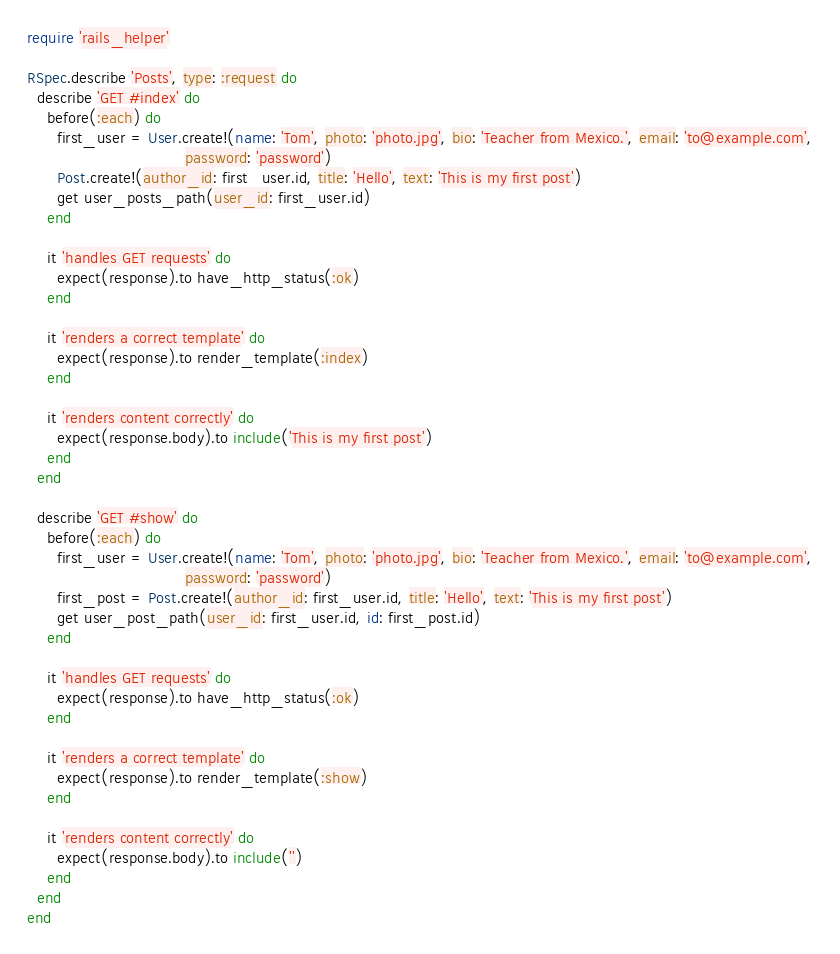<code> <loc_0><loc_0><loc_500><loc_500><_Ruby_>require 'rails_helper'

RSpec.describe 'Posts', type: :request do
  describe 'GET #index' do
    before(:each) do
      first_user = User.create!(name: 'Tom', photo: 'photo.jpg', bio: 'Teacher from Mexico.', email: 'to@example.com',
                                password: 'password')
      Post.create!(author_id: first_user.id, title: 'Hello', text: 'This is my first post')
      get user_posts_path(user_id: first_user.id)
    end

    it 'handles GET requests' do
      expect(response).to have_http_status(:ok)
    end

    it 'renders a correct template' do
      expect(response).to render_template(:index)
    end

    it 'renders content correctly' do
      expect(response.body).to include('This is my first post')
    end
  end

  describe 'GET #show' do
    before(:each) do
      first_user = User.create!(name: 'Tom', photo: 'photo.jpg', bio: 'Teacher from Mexico.', email: 'to@example.com',
                                password: 'password')
      first_post = Post.create!(author_id: first_user.id, title: 'Hello', text: 'This is my first post')
      get user_post_path(user_id: first_user.id, id: first_post.id)
    end

    it 'handles GET requests' do
      expect(response).to have_http_status(:ok)
    end

    it 'renders a correct template' do
      expect(response).to render_template(:show)
    end

    it 'renders content correctly' do
      expect(response.body).to include('')
    end
  end
end
</code> 